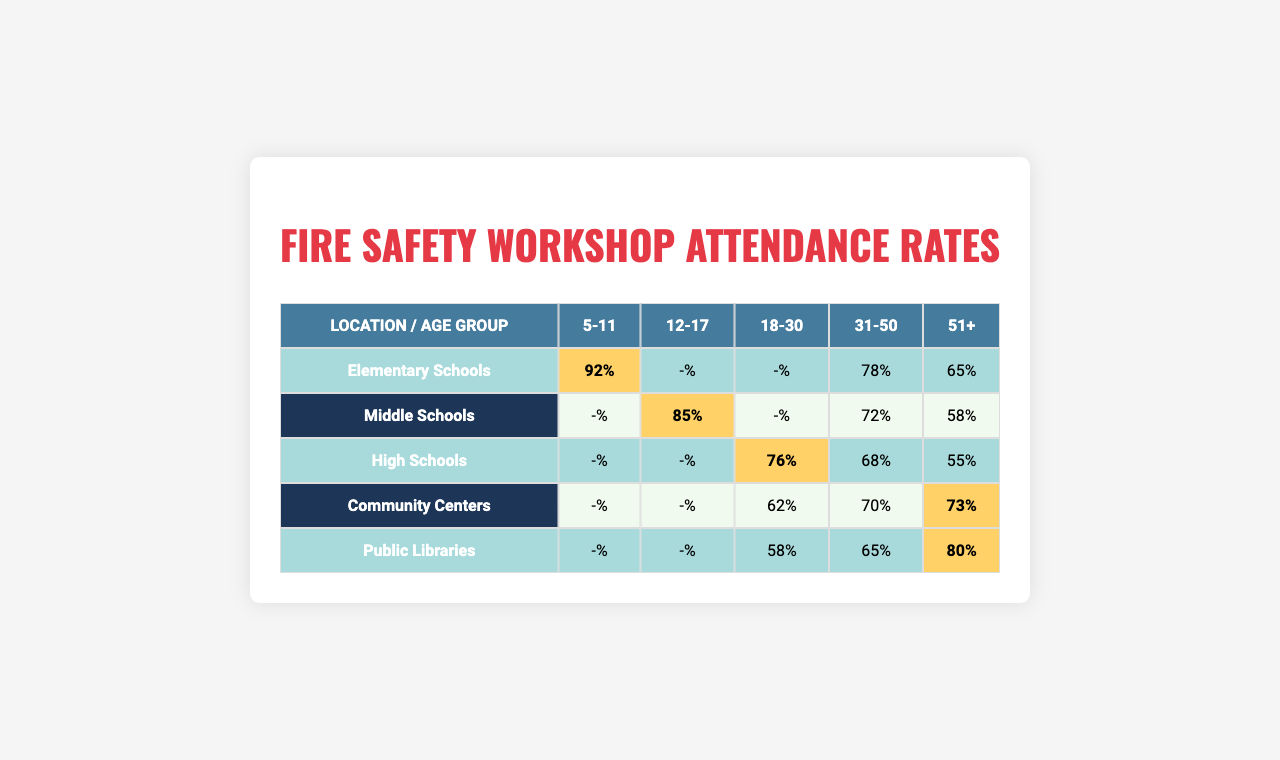What is the attendance rate for the age group 5-11 in Elementary Schools? The table shows that the attendance rate for the age group 5-11 in Elementary Schools is 92%.
Answer: 92% Which age group has the highest attendance rate at Community Centers? The highest attendance rate at Community Centers is 73% for the age group 51+.
Answer: 51+ What is the average attendance rate for the age group 12-17 across all locations? The attendance rates for the 12-17 age group are 0 (Elementary Schools), 85 (Middle Schools), 0 (High Schools), 0 (Community Centers), and 0 (Public Libraries). Summing these gives 85. Since there are 5 locations, the average attendance rate is 85/5 = 17%.
Answer: 17% Does the attendance rate for the age group 18-30 in High Schools exceed that in Middle Schools? The attendance rate for 18-30 in High Schools is 76% and in Middle Schools is 0%. Since 76% is greater than 0%, the attendance rate in High Schools does exceed that in Middle Schools.
Answer: Yes Which location has the second highest attendance rate for the age group 31-50? The attendance rates for the age group 31-50 are 78% (Elementary Schools), 72% (Middle Schools), 68% (High Schools), 70% (Community Centers), and 65% (Public Libraries). The highest is 78%, and the second highest is 72% from Middle Schools.
Answer: Middle Schools What is the total attendance rate for the age group 51+ across all locations? The attendance rates for the 51+ age group are 65% (Elementary Schools), 58% (Middle Schools), 55% (High Schools), 73% (Community Centers), and 80% (Public Libraries). Summing these gives 65 + 58 + 55 + 73 + 80 = 331%.
Answer: 331% Is the attendance rate for the age group 12-17 in High Schools higher than that in Public Libraries? The attendance rate for the age group 12-17 in High Schools is 0% and in Public Libraries is also 0%. Since both are equal, the rate in High Schools is not higher.
Answer: No What is the difference in attendance rates for age group 5-11 between Elementary Schools and Public Libraries? The attendance rate for age group 5-11 in Elementary Schools is 92% and in Public Libraries it is 0%. The difference is 92 - 0 = 92%.
Answer: 92% Which group has the lowest attendance rate for age group 12-17? The attendance rates for age group 12-17 in Elementary Schools, High Schools, Community Centers, and Public Libraries are all 0%. Thus, both Elementary Schools, High Schools, Community Centers, and Public Libraries have the lowest attendance rate.
Answer: All of them What is the median attendance rate for the age group 31-50 across all locations? The attendance rates for age group 31-50 are 78% (Elementary Schools), 72% (Middle Schools), 68% (High Schools), 70% (Community Centers), and 65% (Public Libraries). Arranging these in numeric order gives 65%, 68%, 70%, 72%, and 78%. The median of these values is the middle value, which is 70%.
Answer: 70% 